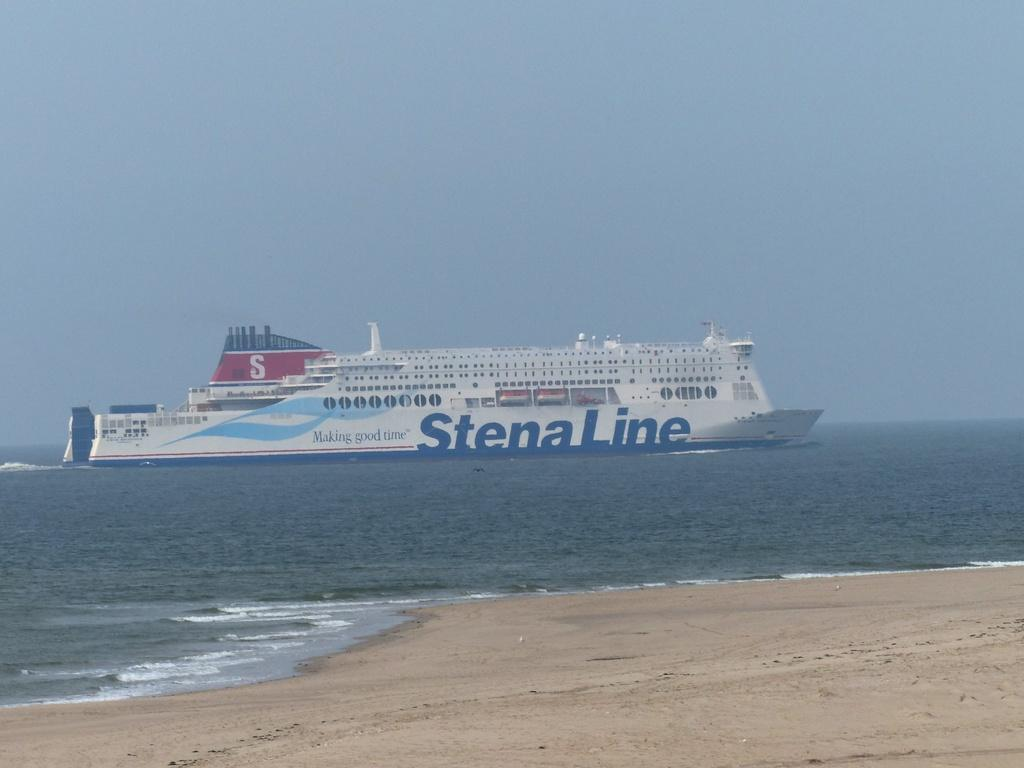What is the main subject of the image? The main subject of the image is a ship. Where is the ship located? The ship is in the water. What can be seen on the ship? There is writing on the ship. What is the terrain in front of the ship? There is sand in front of the ship. What can be seen in the background of the image? The sky is visible in the background. How many sofas are visible in the image? There are no sofas present in the image. What type of sea creature can be seen swimming near the ship? There is no sea creature visible in the image; it only features a ship in the water. 